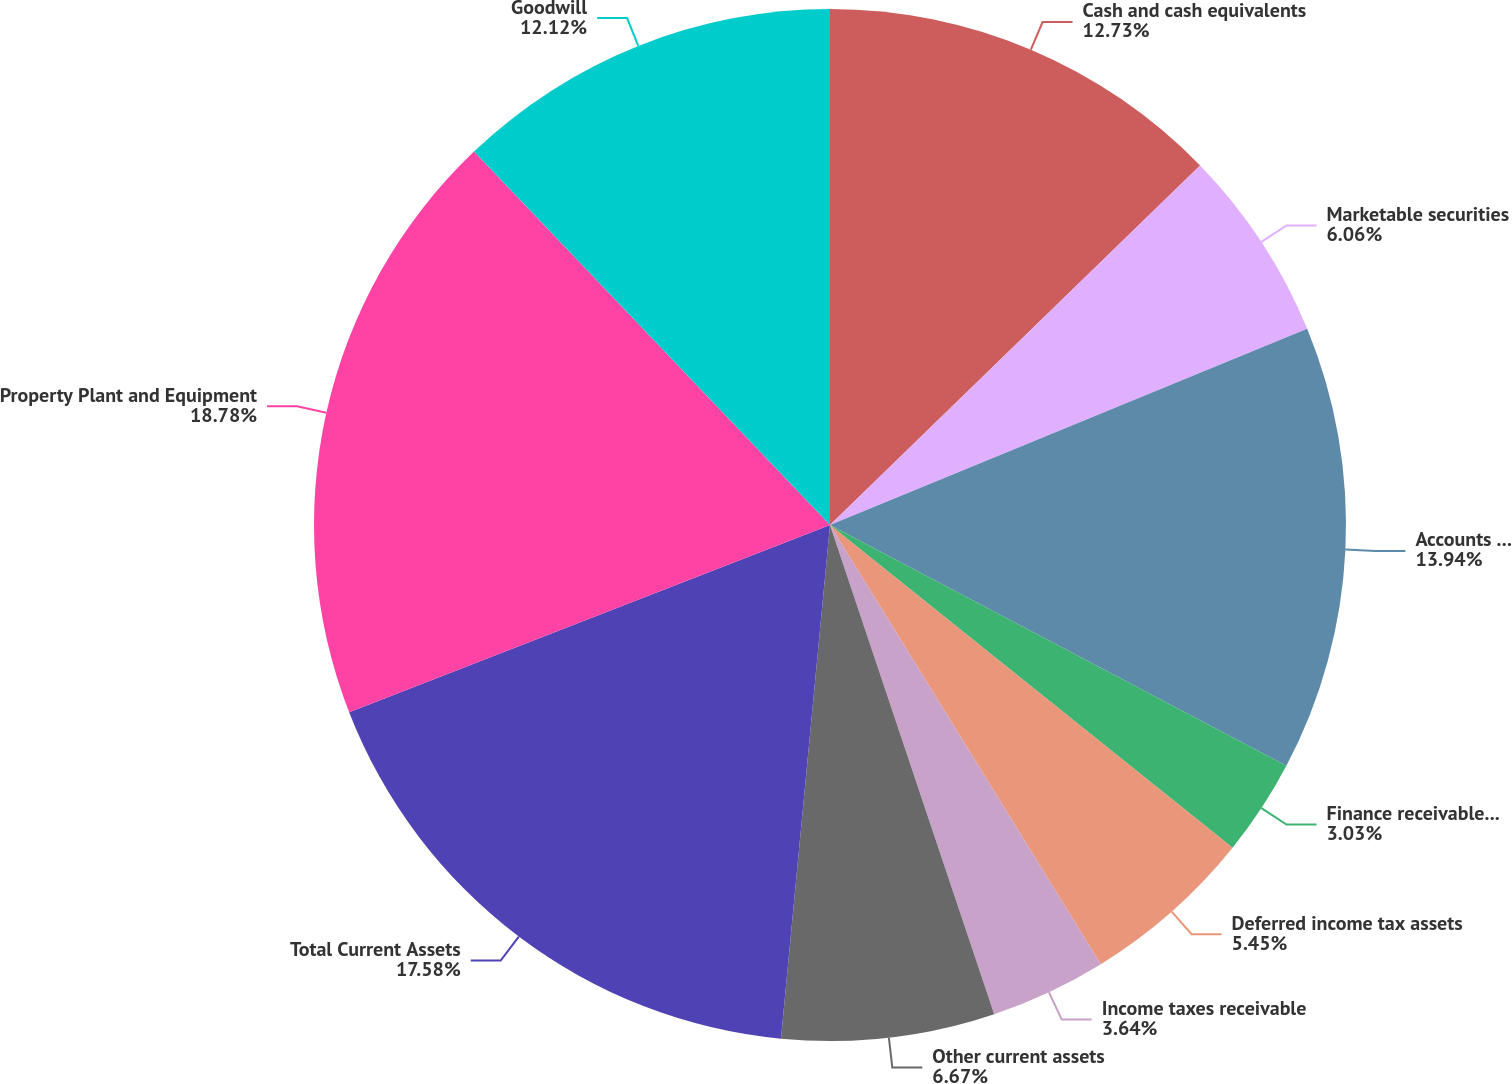<chart> <loc_0><loc_0><loc_500><loc_500><pie_chart><fcel>Cash and cash equivalents<fcel>Marketable securities<fcel>Accounts receivable net<fcel>Finance receivables net<fcel>Deferred income tax assets<fcel>Income taxes receivable<fcel>Other current assets<fcel>Total Current Assets<fcel>Property Plant and Equipment<fcel>Goodwill<nl><fcel>12.73%<fcel>6.06%<fcel>13.94%<fcel>3.03%<fcel>5.45%<fcel>3.64%<fcel>6.67%<fcel>17.58%<fcel>18.79%<fcel>12.12%<nl></chart> 